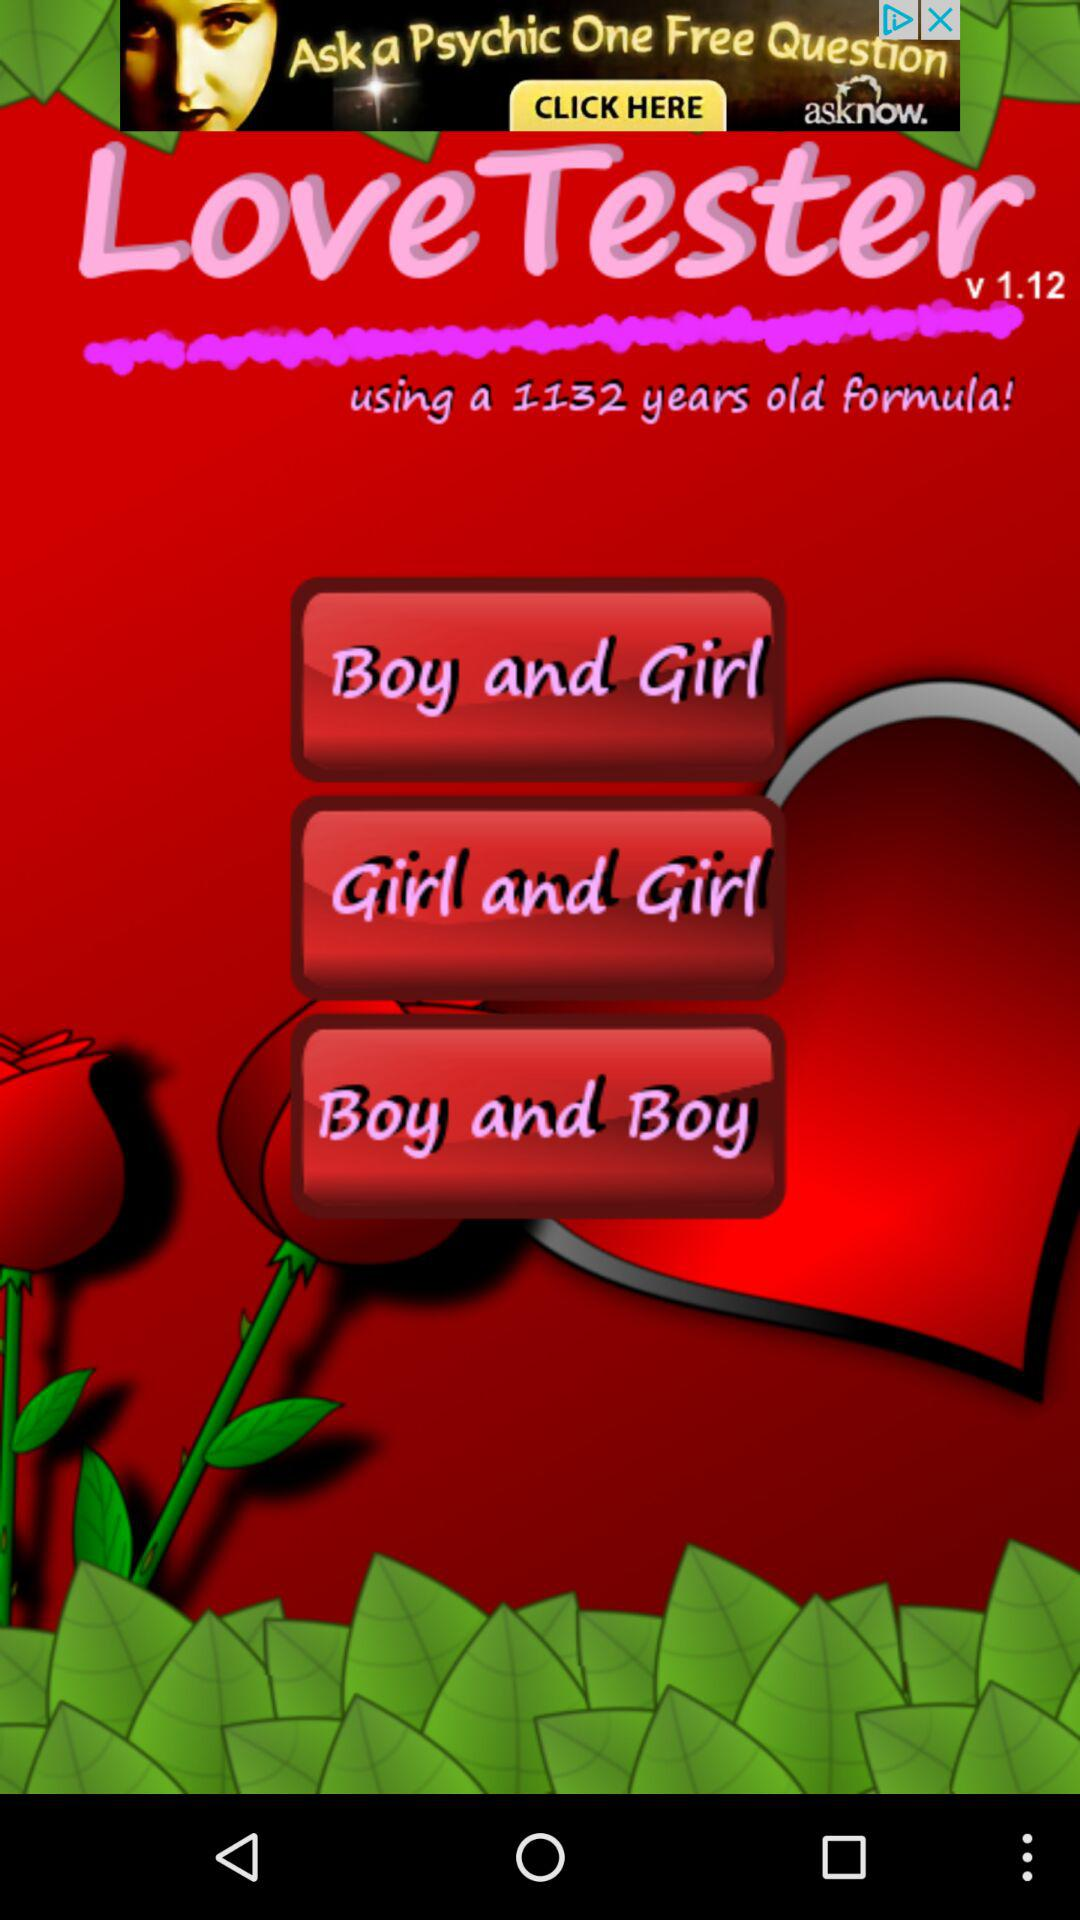What is the name of the application? The name of the application is "LoveTester". 